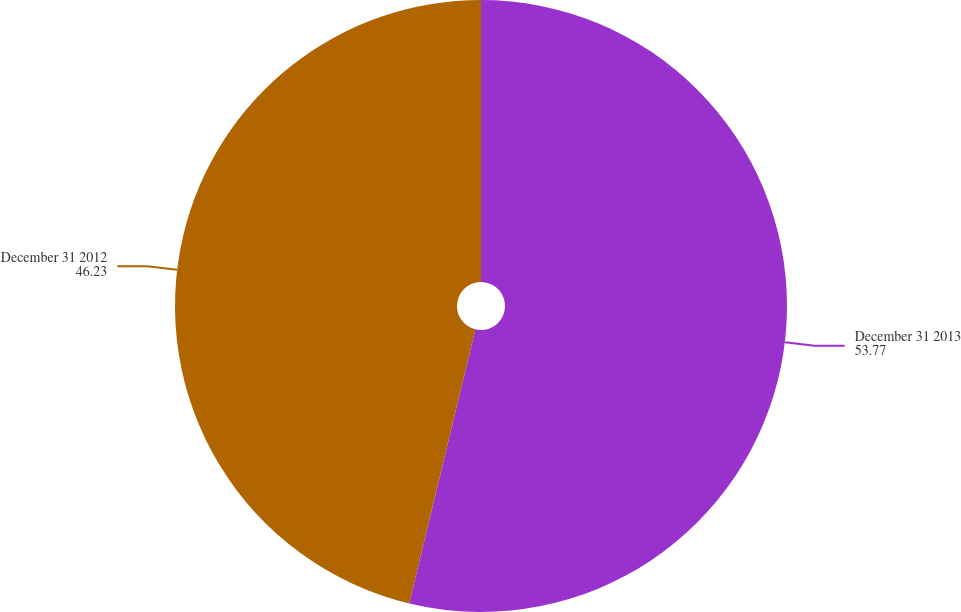Convert chart to OTSL. <chart><loc_0><loc_0><loc_500><loc_500><pie_chart><fcel>December 31 2013<fcel>December 31 2012<nl><fcel>53.77%<fcel>46.23%<nl></chart> 